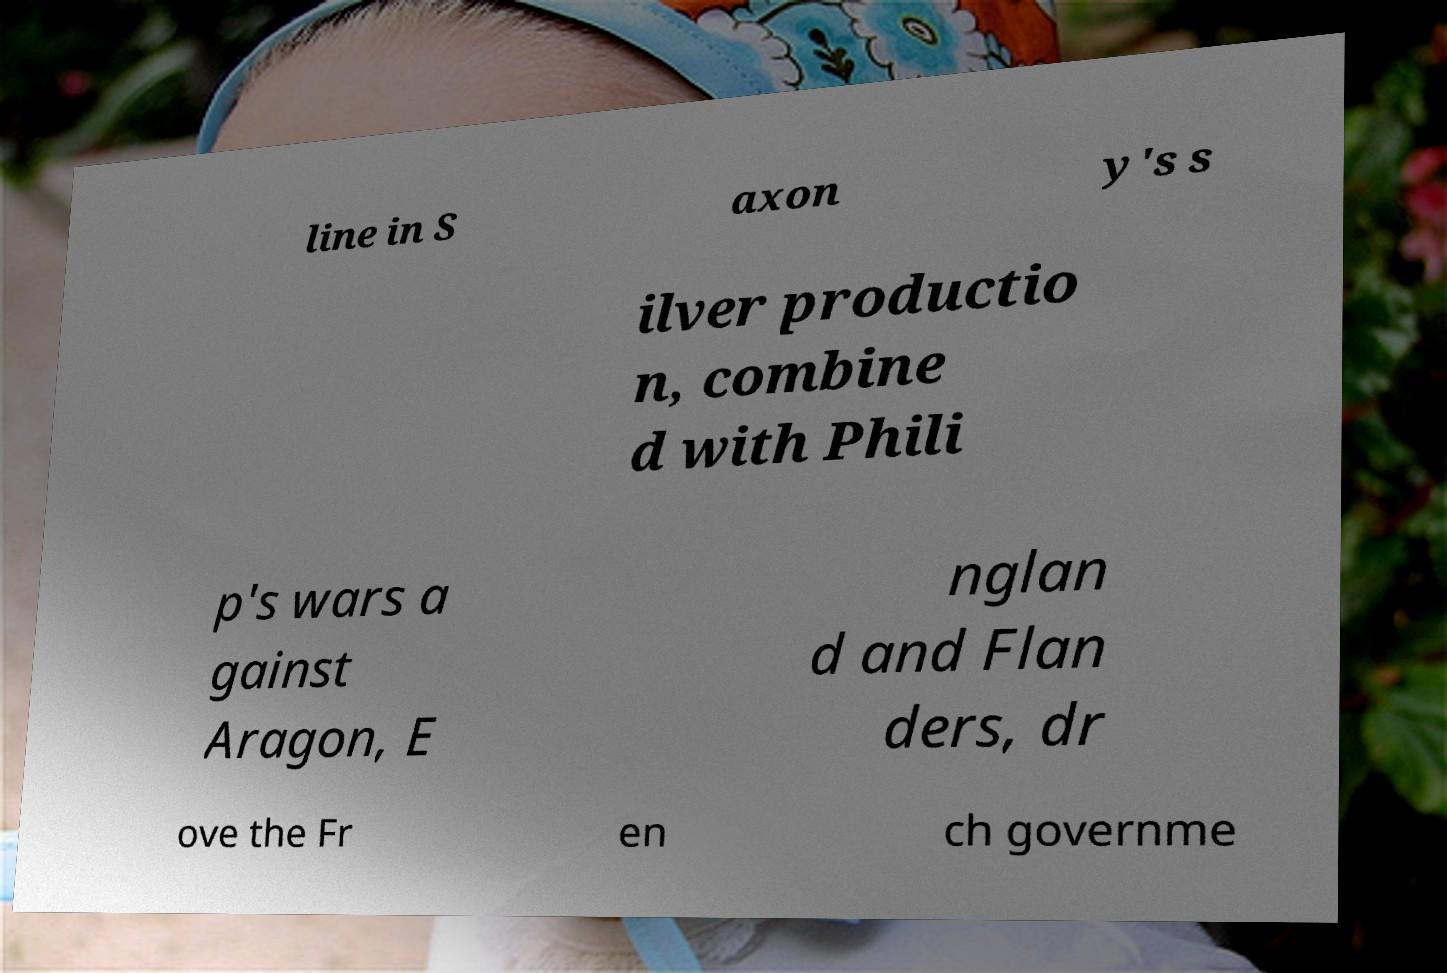For documentation purposes, I need the text within this image transcribed. Could you provide that? line in S axon y's s ilver productio n, combine d with Phili p's wars a gainst Aragon, E nglan d and Flan ders, dr ove the Fr en ch governme 